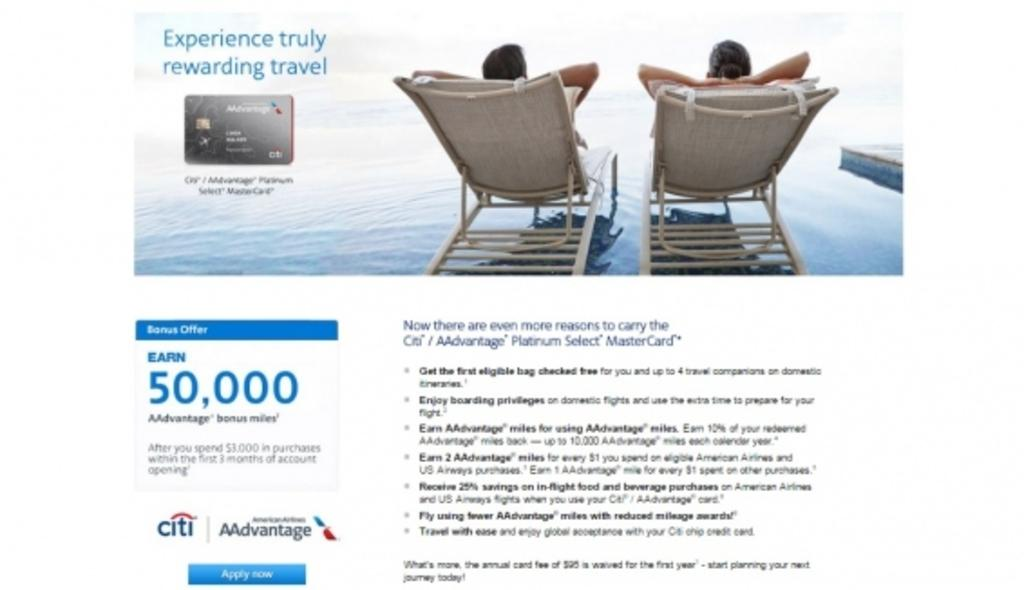How many people are in the image? There are two persons in the image. What are the persons doing in the image? The persons are sitting in chairs. Where are the chairs located? The chairs are on the water. What can be seen beside and below the chairs? There is text written beside and below the chairs. What type of cloud is floating above the crib in the image? There is no cloud or crib present in the image. How much debt is visible in the image? There is no mention of debt in the image. 